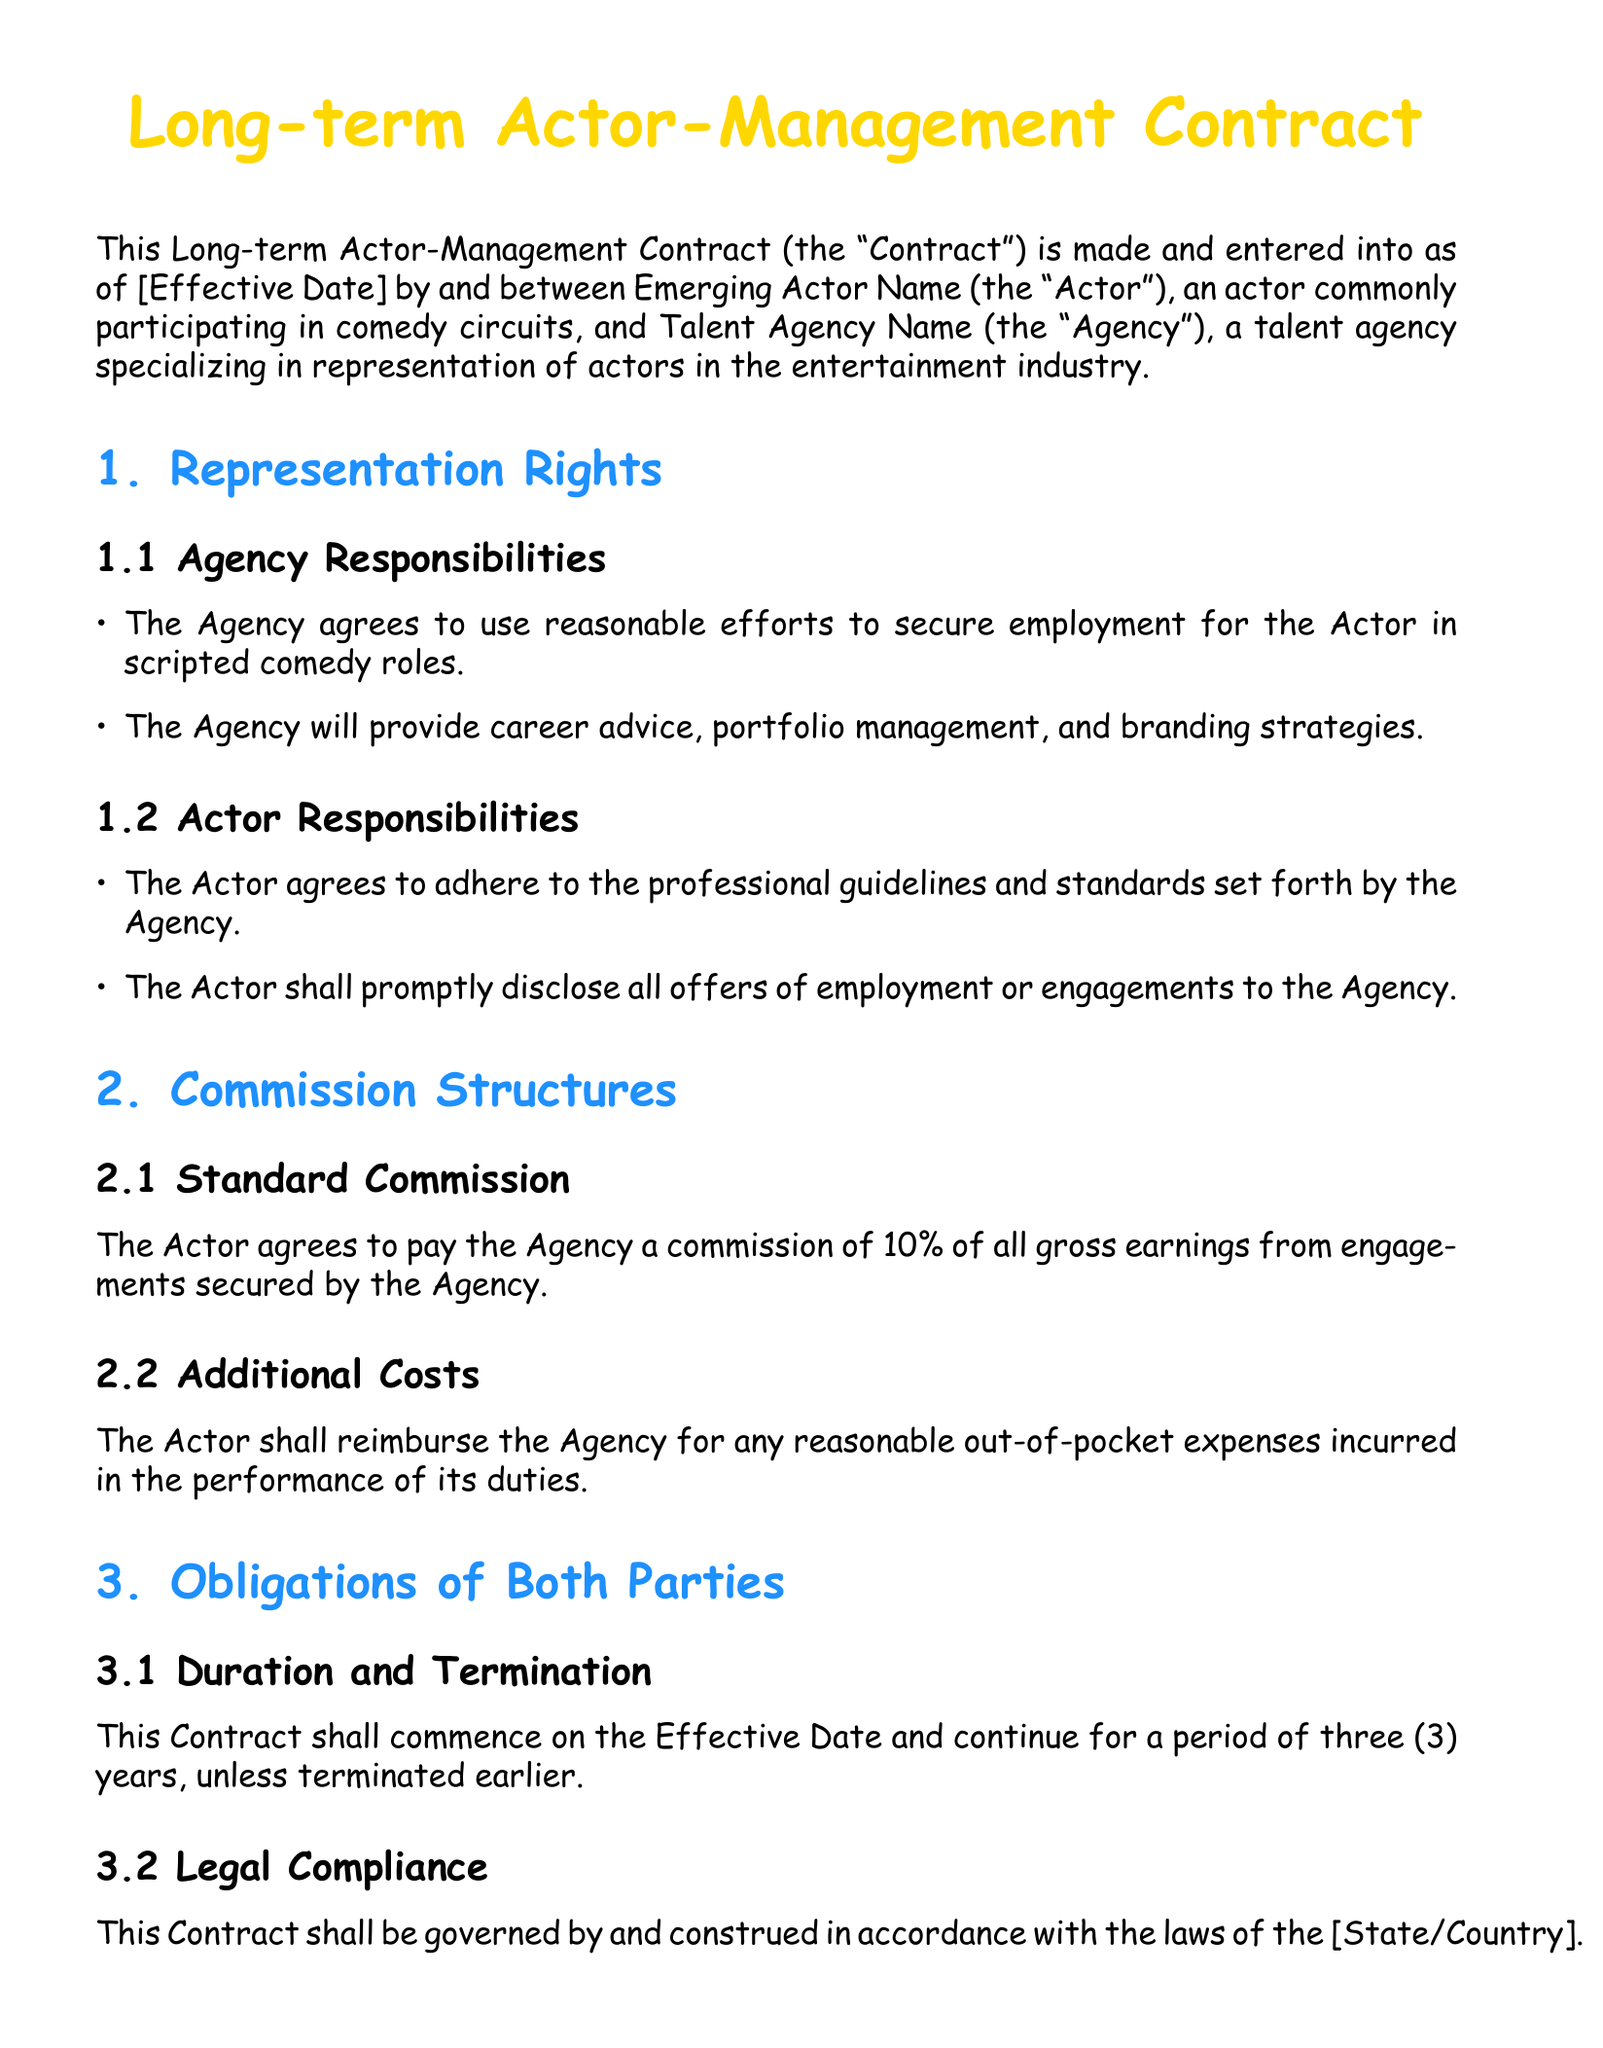What is the effective date of the contract? The effective date is indicated as [Effective Date] and is not specified in the document.
Answer: [Effective Date] What is the commission percentage the actor agrees to pay the agency? The document states that the actor agrees to pay a commission of 10% of all gross earnings from engagements secured by the agency.
Answer: 10% What is the duration of the contract? The duration of the contract is specified as three years, unless terminated earlier.
Answer: three years What are the agency's responsibilities towards the actor? The agency's responsibilities include securing employment for the actor in scripted comedy roles and providing career advice.
Answer: securing employment and career advice What obligations do both parties have concerning confidentiality? Both parties agree to maintain the confidentiality of any non-public information obtained during the contract term.
Answer: maintain confidentiality What type of roles does the agency agree to focus on for the actor? The agency agrees to focus on securing employment specifically in scripted comedy roles for the actor.
Answer: scripted comedy roles Who is the actor mentioned in the contract? The actor is referred to as Emerging Actor Name in the contract.
Answer: Emerging Actor Name What must the actor disclose to the agency? The actor is obligated to promptly disclose all offers of employment or engagements to the agency.
Answer: all offers of employment 